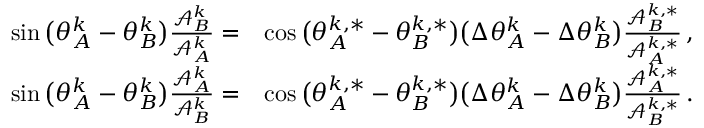<formula> <loc_0><loc_0><loc_500><loc_500>\begin{array} { r l } { \sin \left ( \theta _ { A } ^ { k } - \theta _ { B } ^ { k } \right ) \frac { \mathcal { A } _ { B } ^ { k } } { \mathcal { A } _ { A } ^ { k } } = } & { \cos \left ( \theta _ { A } ^ { k , * } - \theta _ { B } ^ { k , * } \right ) \left ( \Delta \theta _ { A } ^ { k } - \Delta \theta _ { B } ^ { k } \right ) \frac { \mathcal { A } _ { B } ^ { k , * } } { \mathcal { A } _ { A } ^ { k , * } } \, , } \\ { \sin \left ( \theta _ { A } ^ { k } - \theta _ { B } ^ { k } \right ) \frac { \mathcal { A } _ { A } ^ { k } } { \mathcal { A } _ { B } ^ { k } } = } & { \cos \left ( \theta _ { A } ^ { k , * } - \theta _ { B } ^ { k , * } \right ) \left ( \Delta \theta _ { A } ^ { k } - \Delta \theta _ { B } ^ { k } \right ) \frac { \mathcal { A } _ { A } ^ { k , * } } { \mathcal { A } _ { B } ^ { k , * } } \, . } \end{array}</formula> 